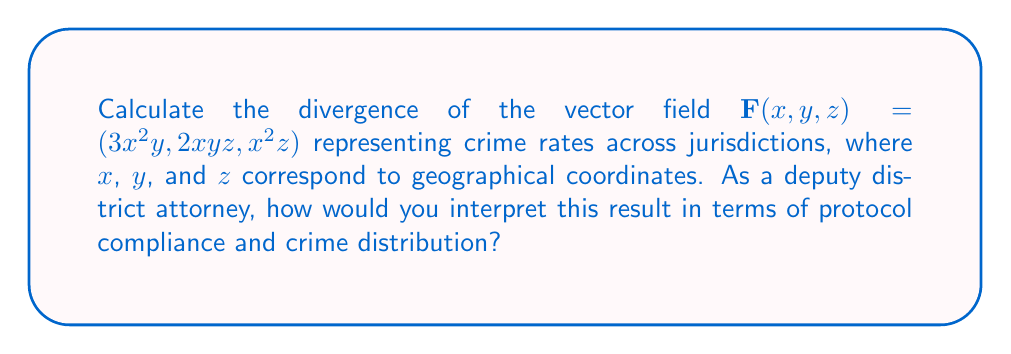Can you solve this math problem? To calculate the divergence of the vector field $\mathbf{F}(x, y, z) = (3x^2y, 2xyz, x^2z)$, we need to follow these steps:

1) The divergence of a vector field $\mathbf{F}(x, y, z) = (F_1, F_2, F_3)$ is given by:

   $$\text{div}\mathbf{F} = \nabla \cdot \mathbf{F} = \frac{\partial F_1}{\partial x} + \frac{\partial F_2}{\partial y} + \frac{\partial F_3}{\partial z}$$

2) Let's identify each component:
   $F_1 = 3x^2y$
   $F_2 = 2xyz$
   $F_3 = x^2z$

3) Now, let's calculate each partial derivative:

   $\frac{\partial F_1}{\partial x} = \frac{\partial}{\partial x}(3x^2y) = 6xy$

   $\frac{\partial F_2}{\partial y} = \frac{\partial}{\partial y}(2xyz) = 2xz$

   $\frac{\partial F_3}{\partial z} = \frac{\partial}{\partial z}(x^2z) = x^2$

4) Sum these partial derivatives:

   $$\text{div}\mathbf{F} = 6xy + 2xz + x^2$$

5) This result can be factored as:

   $$\text{div}\mathbf{F} = x(6y + 2z + x)$$

Interpretation: As a deputy district attorney, this divergence represents the rate at which crime is "flowing" out of a point in the jurisdiction. A positive divergence (which occurs when $6y + 2z + x > 0$) indicates areas where crime rates are increasing, potentially due to lack of protocol compliance. Negative divergence suggests areas where crime rates are decreasing, possibly due to stricter adherence to protocols. The varying divergence across different coordinates implies that crime rates and protocol effectiveness are not uniform across jurisdictions, warranting further investigation into local law enforcement practices.
Answer: $x(6y + 2z + x)$ 